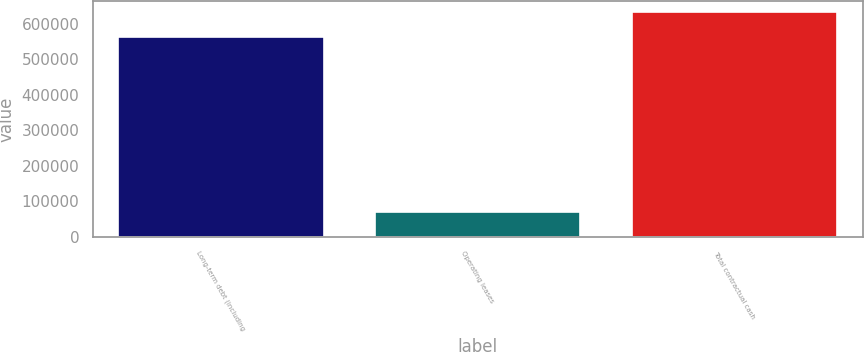Convert chart to OTSL. <chart><loc_0><loc_0><loc_500><loc_500><bar_chart><fcel>Long-term debt (including<fcel>Operating leases<fcel>Total contractual cash<nl><fcel>563792<fcel>69100<fcel>632892<nl></chart> 